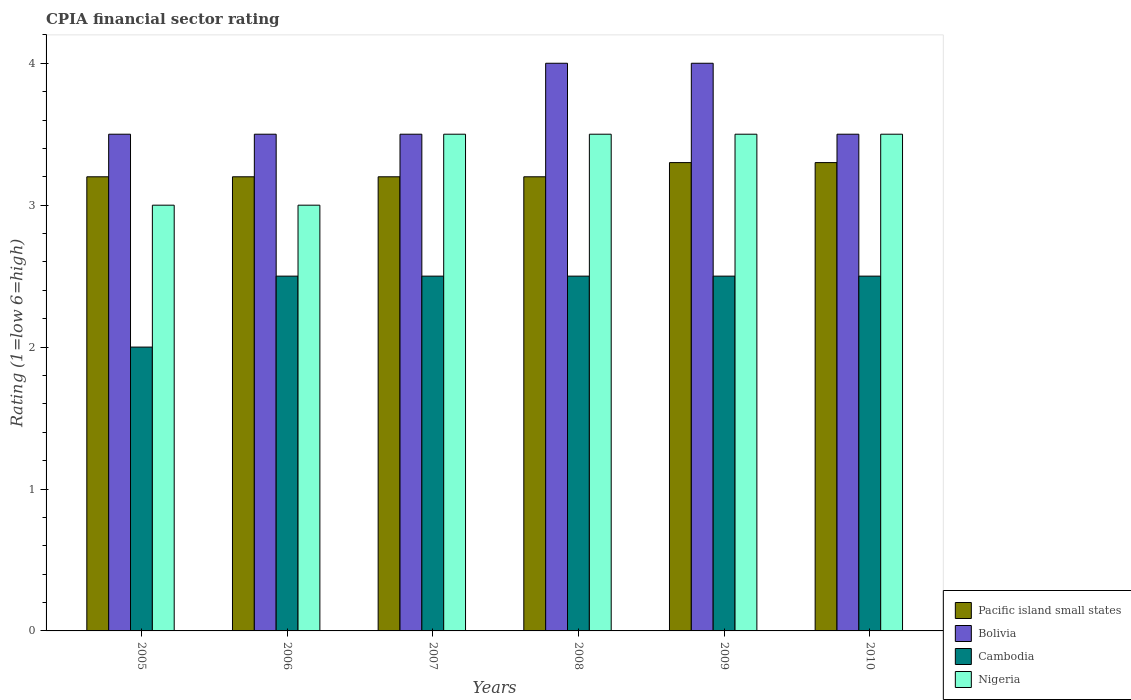How many different coloured bars are there?
Provide a short and direct response. 4. How many groups of bars are there?
Your response must be concise. 6. Are the number of bars per tick equal to the number of legend labels?
Your answer should be very brief. Yes. In how many cases, is the number of bars for a given year not equal to the number of legend labels?
Ensure brevity in your answer.  0. What is the CPIA rating in Nigeria in 2010?
Your answer should be very brief. 3.5. Across all years, what is the minimum CPIA rating in Nigeria?
Provide a short and direct response. 3. In which year was the CPIA rating in Cambodia maximum?
Provide a succinct answer. 2006. What is the total CPIA rating in Bolivia in the graph?
Your answer should be compact. 22. What is the difference between the CPIA rating in Bolivia in 2010 and the CPIA rating in Pacific island small states in 2006?
Provide a succinct answer. 0.3. What is the average CPIA rating in Pacific island small states per year?
Your answer should be compact. 3.23. In the year 2006, what is the difference between the CPIA rating in Cambodia and CPIA rating in Bolivia?
Make the answer very short. -1. What is the ratio of the CPIA rating in Nigeria in 2007 to that in 2010?
Give a very brief answer. 1. Is the difference between the CPIA rating in Cambodia in 2007 and 2010 greater than the difference between the CPIA rating in Bolivia in 2007 and 2010?
Your answer should be compact. No. What is the difference between the highest and the lowest CPIA rating in Pacific island small states?
Offer a terse response. 0.1. Is the sum of the CPIA rating in Cambodia in 2009 and 2010 greater than the maximum CPIA rating in Pacific island small states across all years?
Ensure brevity in your answer.  Yes. What does the 1st bar from the left in 2007 represents?
Give a very brief answer. Pacific island small states. What does the 4th bar from the right in 2008 represents?
Offer a terse response. Pacific island small states. Is it the case that in every year, the sum of the CPIA rating in Nigeria and CPIA rating in Bolivia is greater than the CPIA rating in Pacific island small states?
Your answer should be compact. Yes. Are all the bars in the graph horizontal?
Provide a short and direct response. No. Does the graph contain any zero values?
Make the answer very short. No. Does the graph contain grids?
Your answer should be compact. No. Where does the legend appear in the graph?
Your response must be concise. Bottom right. What is the title of the graph?
Your answer should be very brief. CPIA financial sector rating. Does "Europe(all income levels)" appear as one of the legend labels in the graph?
Your response must be concise. No. What is the label or title of the X-axis?
Keep it short and to the point. Years. What is the Rating (1=low 6=high) of Pacific island small states in 2005?
Keep it short and to the point. 3.2. What is the Rating (1=low 6=high) of Bolivia in 2005?
Offer a terse response. 3.5. What is the Rating (1=low 6=high) of Cambodia in 2005?
Your answer should be compact. 2. What is the Rating (1=low 6=high) of Bolivia in 2006?
Your answer should be very brief. 3.5. What is the Rating (1=low 6=high) of Cambodia in 2006?
Offer a very short reply. 2.5. What is the Rating (1=low 6=high) of Nigeria in 2006?
Make the answer very short. 3. What is the Rating (1=low 6=high) of Pacific island small states in 2007?
Your answer should be compact. 3.2. What is the Rating (1=low 6=high) of Nigeria in 2007?
Give a very brief answer. 3.5. What is the Rating (1=low 6=high) in Bolivia in 2008?
Your response must be concise. 4. What is the Rating (1=low 6=high) in Cambodia in 2008?
Provide a succinct answer. 2.5. What is the Rating (1=low 6=high) of Nigeria in 2008?
Ensure brevity in your answer.  3.5. What is the Rating (1=low 6=high) in Bolivia in 2009?
Offer a very short reply. 4. What is the Rating (1=low 6=high) in Cambodia in 2009?
Give a very brief answer. 2.5. What is the Rating (1=low 6=high) in Nigeria in 2009?
Provide a short and direct response. 3.5. What is the Rating (1=low 6=high) of Bolivia in 2010?
Keep it short and to the point. 3.5. What is the Rating (1=low 6=high) in Cambodia in 2010?
Provide a short and direct response. 2.5. What is the Rating (1=low 6=high) in Nigeria in 2010?
Offer a very short reply. 3.5. Across all years, what is the maximum Rating (1=low 6=high) of Bolivia?
Your answer should be very brief. 4. Across all years, what is the minimum Rating (1=low 6=high) in Pacific island small states?
Keep it short and to the point. 3.2. Across all years, what is the minimum Rating (1=low 6=high) in Cambodia?
Your answer should be compact. 2. Across all years, what is the minimum Rating (1=low 6=high) of Nigeria?
Provide a short and direct response. 3. What is the total Rating (1=low 6=high) of Pacific island small states in the graph?
Provide a short and direct response. 19.4. What is the total Rating (1=low 6=high) of Cambodia in the graph?
Keep it short and to the point. 14.5. What is the difference between the Rating (1=low 6=high) in Pacific island small states in 2005 and that in 2006?
Keep it short and to the point. 0. What is the difference between the Rating (1=low 6=high) of Bolivia in 2005 and that in 2006?
Make the answer very short. 0. What is the difference between the Rating (1=low 6=high) in Cambodia in 2005 and that in 2007?
Offer a terse response. -0.5. What is the difference between the Rating (1=low 6=high) of Bolivia in 2005 and that in 2008?
Provide a succinct answer. -0.5. What is the difference between the Rating (1=low 6=high) of Cambodia in 2005 and that in 2009?
Provide a succinct answer. -0.5. What is the difference between the Rating (1=low 6=high) of Nigeria in 2005 and that in 2009?
Provide a succinct answer. -0.5. What is the difference between the Rating (1=low 6=high) in Pacific island small states in 2005 and that in 2010?
Give a very brief answer. -0.1. What is the difference between the Rating (1=low 6=high) in Bolivia in 2005 and that in 2010?
Give a very brief answer. 0. What is the difference between the Rating (1=low 6=high) of Cambodia in 2005 and that in 2010?
Give a very brief answer. -0.5. What is the difference between the Rating (1=low 6=high) in Nigeria in 2005 and that in 2010?
Keep it short and to the point. -0.5. What is the difference between the Rating (1=low 6=high) of Pacific island small states in 2006 and that in 2007?
Give a very brief answer. 0. What is the difference between the Rating (1=low 6=high) of Pacific island small states in 2006 and that in 2008?
Give a very brief answer. 0. What is the difference between the Rating (1=low 6=high) in Bolivia in 2006 and that in 2008?
Make the answer very short. -0.5. What is the difference between the Rating (1=low 6=high) of Bolivia in 2006 and that in 2009?
Your response must be concise. -0.5. What is the difference between the Rating (1=low 6=high) of Nigeria in 2006 and that in 2009?
Your answer should be compact. -0.5. What is the difference between the Rating (1=low 6=high) of Cambodia in 2006 and that in 2010?
Provide a short and direct response. 0. What is the difference between the Rating (1=low 6=high) of Nigeria in 2006 and that in 2010?
Make the answer very short. -0.5. What is the difference between the Rating (1=low 6=high) in Pacific island small states in 2007 and that in 2008?
Make the answer very short. 0. What is the difference between the Rating (1=low 6=high) in Nigeria in 2007 and that in 2008?
Provide a succinct answer. 0. What is the difference between the Rating (1=low 6=high) of Pacific island small states in 2007 and that in 2009?
Your response must be concise. -0.1. What is the difference between the Rating (1=low 6=high) in Bolivia in 2007 and that in 2010?
Offer a terse response. 0. What is the difference between the Rating (1=low 6=high) of Cambodia in 2007 and that in 2010?
Your answer should be very brief. 0. What is the difference between the Rating (1=low 6=high) of Cambodia in 2008 and that in 2009?
Keep it short and to the point. 0. What is the difference between the Rating (1=low 6=high) in Nigeria in 2008 and that in 2009?
Make the answer very short. 0. What is the difference between the Rating (1=low 6=high) of Nigeria in 2008 and that in 2010?
Your answer should be very brief. 0. What is the difference between the Rating (1=low 6=high) of Pacific island small states in 2009 and that in 2010?
Your answer should be very brief. 0. What is the difference between the Rating (1=low 6=high) of Bolivia in 2009 and that in 2010?
Provide a short and direct response. 0.5. What is the difference between the Rating (1=low 6=high) in Cambodia in 2009 and that in 2010?
Ensure brevity in your answer.  0. What is the difference between the Rating (1=low 6=high) of Bolivia in 2005 and the Rating (1=low 6=high) of Cambodia in 2006?
Ensure brevity in your answer.  1. What is the difference between the Rating (1=low 6=high) in Bolivia in 2005 and the Rating (1=low 6=high) in Nigeria in 2006?
Ensure brevity in your answer.  0.5. What is the difference between the Rating (1=low 6=high) in Cambodia in 2005 and the Rating (1=low 6=high) in Nigeria in 2006?
Offer a terse response. -1. What is the difference between the Rating (1=low 6=high) in Pacific island small states in 2005 and the Rating (1=low 6=high) in Bolivia in 2007?
Provide a succinct answer. -0.3. What is the difference between the Rating (1=low 6=high) of Bolivia in 2005 and the Rating (1=low 6=high) of Cambodia in 2007?
Make the answer very short. 1. What is the difference between the Rating (1=low 6=high) in Bolivia in 2005 and the Rating (1=low 6=high) in Nigeria in 2007?
Your answer should be compact. 0. What is the difference between the Rating (1=low 6=high) of Pacific island small states in 2005 and the Rating (1=low 6=high) of Bolivia in 2008?
Offer a very short reply. -0.8. What is the difference between the Rating (1=low 6=high) in Pacific island small states in 2005 and the Rating (1=low 6=high) in Nigeria in 2008?
Your answer should be compact. -0.3. What is the difference between the Rating (1=low 6=high) of Pacific island small states in 2005 and the Rating (1=low 6=high) of Bolivia in 2009?
Keep it short and to the point. -0.8. What is the difference between the Rating (1=low 6=high) of Pacific island small states in 2005 and the Rating (1=low 6=high) of Cambodia in 2009?
Offer a terse response. 0.7. What is the difference between the Rating (1=low 6=high) of Pacific island small states in 2005 and the Rating (1=low 6=high) of Nigeria in 2009?
Provide a succinct answer. -0.3. What is the difference between the Rating (1=low 6=high) of Bolivia in 2005 and the Rating (1=low 6=high) of Cambodia in 2009?
Provide a succinct answer. 1. What is the difference between the Rating (1=low 6=high) in Pacific island small states in 2005 and the Rating (1=low 6=high) in Bolivia in 2010?
Your answer should be compact. -0.3. What is the difference between the Rating (1=low 6=high) of Pacific island small states in 2005 and the Rating (1=low 6=high) of Cambodia in 2010?
Give a very brief answer. 0.7. What is the difference between the Rating (1=low 6=high) in Pacific island small states in 2005 and the Rating (1=low 6=high) in Nigeria in 2010?
Make the answer very short. -0.3. What is the difference between the Rating (1=low 6=high) of Bolivia in 2005 and the Rating (1=low 6=high) of Nigeria in 2010?
Offer a terse response. 0. What is the difference between the Rating (1=low 6=high) in Cambodia in 2005 and the Rating (1=low 6=high) in Nigeria in 2010?
Your answer should be compact. -1.5. What is the difference between the Rating (1=low 6=high) in Pacific island small states in 2006 and the Rating (1=low 6=high) in Nigeria in 2007?
Offer a very short reply. -0.3. What is the difference between the Rating (1=low 6=high) of Cambodia in 2006 and the Rating (1=low 6=high) of Nigeria in 2007?
Offer a very short reply. -1. What is the difference between the Rating (1=low 6=high) of Pacific island small states in 2006 and the Rating (1=low 6=high) of Nigeria in 2008?
Provide a succinct answer. -0.3. What is the difference between the Rating (1=low 6=high) of Bolivia in 2006 and the Rating (1=low 6=high) of Nigeria in 2008?
Offer a very short reply. 0. What is the difference between the Rating (1=low 6=high) of Pacific island small states in 2006 and the Rating (1=low 6=high) of Nigeria in 2009?
Give a very brief answer. -0.3. What is the difference between the Rating (1=low 6=high) in Bolivia in 2006 and the Rating (1=low 6=high) in Cambodia in 2009?
Make the answer very short. 1. What is the difference between the Rating (1=low 6=high) of Bolivia in 2006 and the Rating (1=low 6=high) of Nigeria in 2009?
Your response must be concise. 0. What is the difference between the Rating (1=low 6=high) in Cambodia in 2006 and the Rating (1=low 6=high) in Nigeria in 2009?
Your answer should be very brief. -1. What is the difference between the Rating (1=low 6=high) in Pacific island small states in 2006 and the Rating (1=low 6=high) in Bolivia in 2010?
Make the answer very short. -0.3. What is the difference between the Rating (1=low 6=high) in Bolivia in 2006 and the Rating (1=low 6=high) in Nigeria in 2010?
Ensure brevity in your answer.  0. What is the difference between the Rating (1=low 6=high) in Cambodia in 2006 and the Rating (1=low 6=high) in Nigeria in 2010?
Make the answer very short. -1. What is the difference between the Rating (1=low 6=high) in Pacific island small states in 2007 and the Rating (1=low 6=high) in Cambodia in 2008?
Ensure brevity in your answer.  0.7. What is the difference between the Rating (1=low 6=high) of Bolivia in 2007 and the Rating (1=low 6=high) of Cambodia in 2008?
Provide a short and direct response. 1. What is the difference between the Rating (1=low 6=high) of Cambodia in 2007 and the Rating (1=low 6=high) of Nigeria in 2008?
Offer a very short reply. -1. What is the difference between the Rating (1=low 6=high) of Pacific island small states in 2007 and the Rating (1=low 6=high) of Bolivia in 2009?
Your answer should be very brief. -0.8. What is the difference between the Rating (1=low 6=high) in Pacific island small states in 2007 and the Rating (1=low 6=high) in Cambodia in 2009?
Offer a very short reply. 0.7. What is the difference between the Rating (1=low 6=high) in Pacific island small states in 2007 and the Rating (1=low 6=high) in Nigeria in 2009?
Ensure brevity in your answer.  -0.3. What is the difference between the Rating (1=low 6=high) of Bolivia in 2007 and the Rating (1=low 6=high) of Nigeria in 2009?
Offer a very short reply. 0. What is the difference between the Rating (1=low 6=high) in Pacific island small states in 2007 and the Rating (1=low 6=high) in Nigeria in 2010?
Give a very brief answer. -0.3. What is the difference between the Rating (1=low 6=high) in Bolivia in 2007 and the Rating (1=low 6=high) in Cambodia in 2010?
Offer a very short reply. 1. What is the difference between the Rating (1=low 6=high) in Bolivia in 2007 and the Rating (1=low 6=high) in Nigeria in 2010?
Provide a short and direct response. 0. What is the difference between the Rating (1=low 6=high) of Cambodia in 2007 and the Rating (1=low 6=high) of Nigeria in 2010?
Provide a succinct answer. -1. What is the difference between the Rating (1=low 6=high) of Pacific island small states in 2008 and the Rating (1=low 6=high) of Bolivia in 2009?
Provide a short and direct response. -0.8. What is the difference between the Rating (1=low 6=high) of Pacific island small states in 2008 and the Rating (1=low 6=high) of Cambodia in 2009?
Offer a very short reply. 0.7. What is the difference between the Rating (1=low 6=high) in Pacific island small states in 2008 and the Rating (1=low 6=high) in Nigeria in 2009?
Offer a terse response. -0.3. What is the difference between the Rating (1=low 6=high) in Cambodia in 2008 and the Rating (1=low 6=high) in Nigeria in 2009?
Make the answer very short. -1. What is the difference between the Rating (1=low 6=high) in Pacific island small states in 2008 and the Rating (1=low 6=high) in Cambodia in 2010?
Keep it short and to the point. 0.7. What is the difference between the Rating (1=low 6=high) of Pacific island small states in 2008 and the Rating (1=low 6=high) of Nigeria in 2010?
Offer a very short reply. -0.3. What is the difference between the Rating (1=low 6=high) of Bolivia in 2008 and the Rating (1=low 6=high) of Nigeria in 2010?
Provide a short and direct response. 0.5. What is the difference between the Rating (1=low 6=high) in Cambodia in 2008 and the Rating (1=low 6=high) in Nigeria in 2010?
Provide a succinct answer. -1. What is the difference between the Rating (1=low 6=high) of Pacific island small states in 2009 and the Rating (1=low 6=high) of Bolivia in 2010?
Your answer should be compact. -0.2. What is the difference between the Rating (1=low 6=high) in Pacific island small states in 2009 and the Rating (1=low 6=high) in Cambodia in 2010?
Give a very brief answer. 0.8. What is the difference between the Rating (1=low 6=high) in Pacific island small states in 2009 and the Rating (1=low 6=high) in Nigeria in 2010?
Your answer should be very brief. -0.2. What is the difference between the Rating (1=low 6=high) in Bolivia in 2009 and the Rating (1=low 6=high) in Cambodia in 2010?
Give a very brief answer. 1.5. What is the difference between the Rating (1=low 6=high) of Cambodia in 2009 and the Rating (1=low 6=high) of Nigeria in 2010?
Provide a short and direct response. -1. What is the average Rating (1=low 6=high) in Pacific island small states per year?
Offer a very short reply. 3.23. What is the average Rating (1=low 6=high) in Bolivia per year?
Your answer should be compact. 3.67. What is the average Rating (1=low 6=high) of Cambodia per year?
Keep it short and to the point. 2.42. What is the average Rating (1=low 6=high) of Nigeria per year?
Your answer should be compact. 3.33. In the year 2005, what is the difference between the Rating (1=low 6=high) in Pacific island small states and Rating (1=low 6=high) in Cambodia?
Your answer should be very brief. 1.2. In the year 2005, what is the difference between the Rating (1=low 6=high) of Bolivia and Rating (1=low 6=high) of Cambodia?
Make the answer very short. 1.5. In the year 2005, what is the difference between the Rating (1=low 6=high) in Bolivia and Rating (1=low 6=high) in Nigeria?
Keep it short and to the point. 0.5. In the year 2006, what is the difference between the Rating (1=low 6=high) in Pacific island small states and Rating (1=low 6=high) in Cambodia?
Keep it short and to the point. 0.7. In the year 2006, what is the difference between the Rating (1=low 6=high) in Pacific island small states and Rating (1=low 6=high) in Nigeria?
Provide a short and direct response. 0.2. In the year 2006, what is the difference between the Rating (1=low 6=high) in Bolivia and Rating (1=low 6=high) in Nigeria?
Your answer should be very brief. 0.5. In the year 2006, what is the difference between the Rating (1=low 6=high) in Cambodia and Rating (1=low 6=high) in Nigeria?
Offer a terse response. -0.5. In the year 2007, what is the difference between the Rating (1=low 6=high) in Cambodia and Rating (1=low 6=high) in Nigeria?
Ensure brevity in your answer.  -1. In the year 2008, what is the difference between the Rating (1=low 6=high) of Cambodia and Rating (1=low 6=high) of Nigeria?
Keep it short and to the point. -1. In the year 2009, what is the difference between the Rating (1=low 6=high) in Pacific island small states and Rating (1=low 6=high) in Bolivia?
Your answer should be very brief. -0.7. In the year 2009, what is the difference between the Rating (1=low 6=high) in Pacific island small states and Rating (1=low 6=high) in Cambodia?
Your answer should be very brief. 0.8. In the year 2009, what is the difference between the Rating (1=low 6=high) of Pacific island small states and Rating (1=low 6=high) of Nigeria?
Provide a short and direct response. -0.2. In the year 2010, what is the difference between the Rating (1=low 6=high) in Bolivia and Rating (1=low 6=high) in Cambodia?
Provide a succinct answer. 1. In the year 2010, what is the difference between the Rating (1=low 6=high) of Bolivia and Rating (1=low 6=high) of Nigeria?
Provide a short and direct response. 0. What is the ratio of the Rating (1=low 6=high) in Bolivia in 2005 to that in 2006?
Give a very brief answer. 1. What is the ratio of the Rating (1=low 6=high) of Cambodia in 2005 to that in 2006?
Your answer should be very brief. 0.8. What is the ratio of the Rating (1=low 6=high) in Cambodia in 2005 to that in 2007?
Offer a terse response. 0.8. What is the ratio of the Rating (1=low 6=high) in Nigeria in 2005 to that in 2007?
Give a very brief answer. 0.86. What is the ratio of the Rating (1=low 6=high) of Pacific island small states in 2005 to that in 2009?
Ensure brevity in your answer.  0.97. What is the ratio of the Rating (1=low 6=high) of Bolivia in 2005 to that in 2009?
Ensure brevity in your answer.  0.88. What is the ratio of the Rating (1=low 6=high) of Nigeria in 2005 to that in 2009?
Provide a succinct answer. 0.86. What is the ratio of the Rating (1=low 6=high) of Pacific island small states in 2005 to that in 2010?
Make the answer very short. 0.97. What is the ratio of the Rating (1=low 6=high) in Cambodia in 2005 to that in 2010?
Ensure brevity in your answer.  0.8. What is the ratio of the Rating (1=low 6=high) in Nigeria in 2005 to that in 2010?
Offer a terse response. 0.86. What is the ratio of the Rating (1=low 6=high) of Nigeria in 2006 to that in 2007?
Your answer should be compact. 0.86. What is the ratio of the Rating (1=low 6=high) of Pacific island small states in 2006 to that in 2008?
Offer a terse response. 1. What is the ratio of the Rating (1=low 6=high) of Bolivia in 2006 to that in 2008?
Provide a succinct answer. 0.88. What is the ratio of the Rating (1=low 6=high) in Nigeria in 2006 to that in 2008?
Ensure brevity in your answer.  0.86. What is the ratio of the Rating (1=low 6=high) in Pacific island small states in 2006 to that in 2009?
Keep it short and to the point. 0.97. What is the ratio of the Rating (1=low 6=high) of Bolivia in 2006 to that in 2009?
Your response must be concise. 0.88. What is the ratio of the Rating (1=low 6=high) of Cambodia in 2006 to that in 2009?
Your answer should be compact. 1. What is the ratio of the Rating (1=low 6=high) in Pacific island small states in 2006 to that in 2010?
Make the answer very short. 0.97. What is the ratio of the Rating (1=low 6=high) in Cambodia in 2006 to that in 2010?
Ensure brevity in your answer.  1. What is the ratio of the Rating (1=low 6=high) of Nigeria in 2006 to that in 2010?
Your answer should be very brief. 0.86. What is the ratio of the Rating (1=low 6=high) of Cambodia in 2007 to that in 2008?
Provide a short and direct response. 1. What is the ratio of the Rating (1=low 6=high) in Nigeria in 2007 to that in 2008?
Give a very brief answer. 1. What is the ratio of the Rating (1=low 6=high) of Pacific island small states in 2007 to that in 2009?
Give a very brief answer. 0.97. What is the ratio of the Rating (1=low 6=high) in Cambodia in 2007 to that in 2009?
Your answer should be compact. 1. What is the ratio of the Rating (1=low 6=high) in Pacific island small states in 2007 to that in 2010?
Keep it short and to the point. 0.97. What is the ratio of the Rating (1=low 6=high) of Bolivia in 2007 to that in 2010?
Keep it short and to the point. 1. What is the ratio of the Rating (1=low 6=high) in Cambodia in 2007 to that in 2010?
Offer a very short reply. 1. What is the ratio of the Rating (1=low 6=high) of Nigeria in 2007 to that in 2010?
Ensure brevity in your answer.  1. What is the ratio of the Rating (1=low 6=high) of Pacific island small states in 2008 to that in 2009?
Provide a succinct answer. 0.97. What is the ratio of the Rating (1=low 6=high) of Bolivia in 2008 to that in 2009?
Offer a very short reply. 1. What is the ratio of the Rating (1=low 6=high) of Cambodia in 2008 to that in 2009?
Offer a terse response. 1. What is the ratio of the Rating (1=low 6=high) of Nigeria in 2008 to that in 2009?
Provide a short and direct response. 1. What is the ratio of the Rating (1=low 6=high) in Pacific island small states in 2008 to that in 2010?
Make the answer very short. 0.97. What is the ratio of the Rating (1=low 6=high) of Cambodia in 2008 to that in 2010?
Provide a succinct answer. 1. What is the ratio of the Rating (1=low 6=high) of Bolivia in 2009 to that in 2010?
Ensure brevity in your answer.  1.14. What is the difference between the highest and the second highest Rating (1=low 6=high) in Pacific island small states?
Provide a succinct answer. 0. What is the difference between the highest and the second highest Rating (1=low 6=high) of Cambodia?
Ensure brevity in your answer.  0. What is the difference between the highest and the second highest Rating (1=low 6=high) in Nigeria?
Provide a succinct answer. 0. What is the difference between the highest and the lowest Rating (1=low 6=high) in Cambodia?
Offer a terse response. 0.5. What is the difference between the highest and the lowest Rating (1=low 6=high) in Nigeria?
Provide a short and direct response. 0.5. 